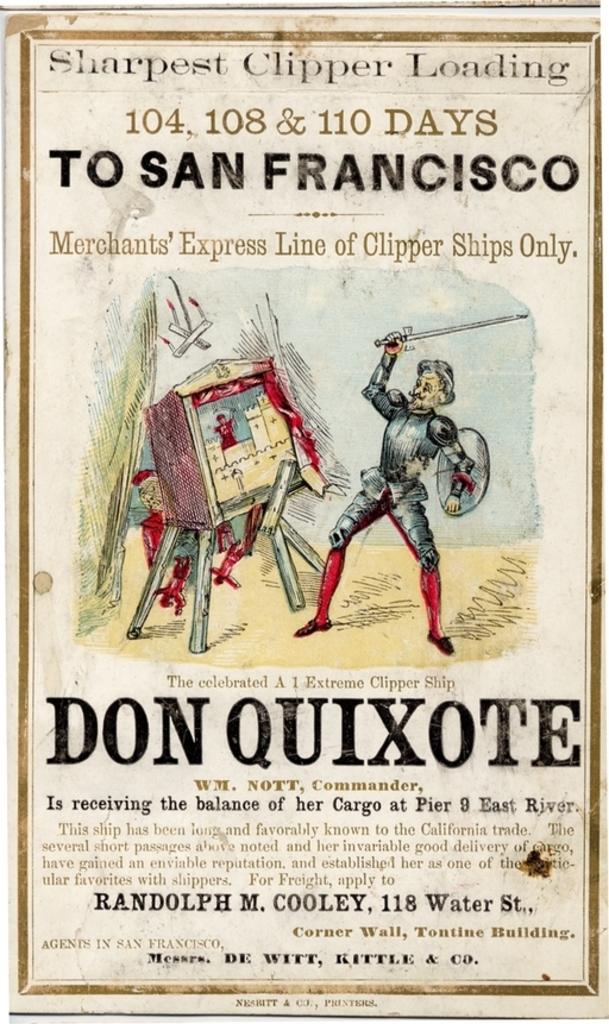What us city is mentioned here?
Make the answer very short. San francisco. 